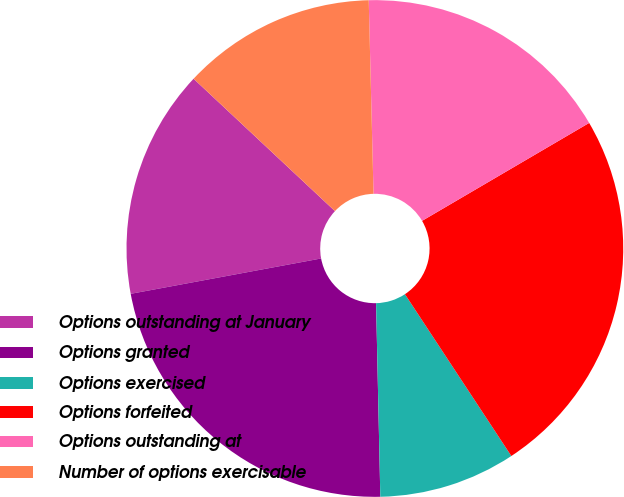Convert chart to OTSL. <chart><loc_0><loc_0><loc_500><loc_500><pie_chart><fcel>Options outstanding at January<fcel>Options granted<fcel>Options exercised<fcel>Options forfeited<fcel>Options outstanding at<fcel>Number of options exercisable<nl><fcel>14.9%<fcel>22.43%<fcel>8.91%<fcel>24.18%<fcel>16.96%<fcel>12.63%<nl></chart> 